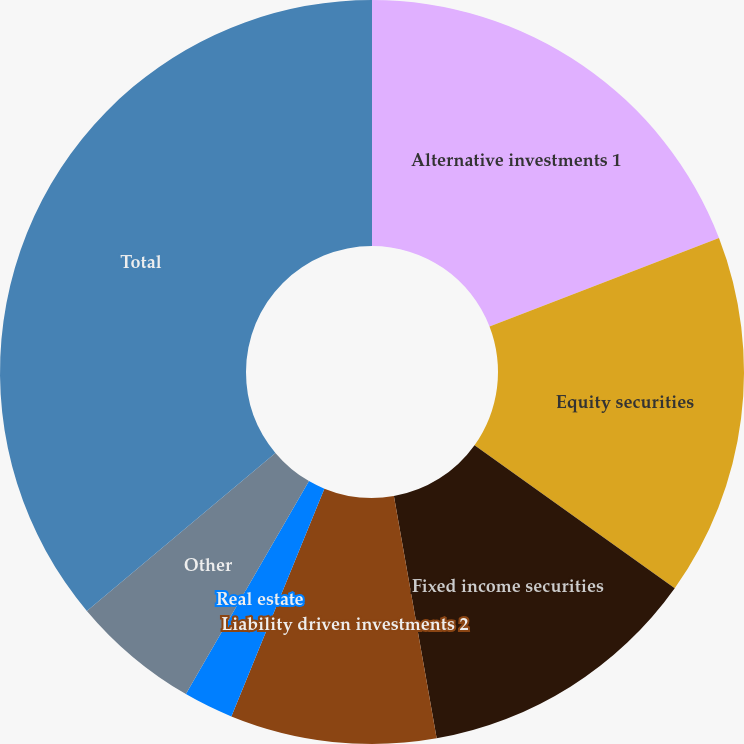<chart> <loc_0><loc_0><loc_500><loc_500><pie_chart><fcel>Alternative investments 1<fcel>Equity securities<fcel>Fixed income securities<fcel>Liability driven investments 2<fcel>Real estate<fcel>Other<fcel>Total<nl><fcel>19.13%<fcel>15.74%<fcel>12.35%<fcel>8.95%<fcel>2.17%<fcel>5.56%<fcel>36.1%<nl></chart> 